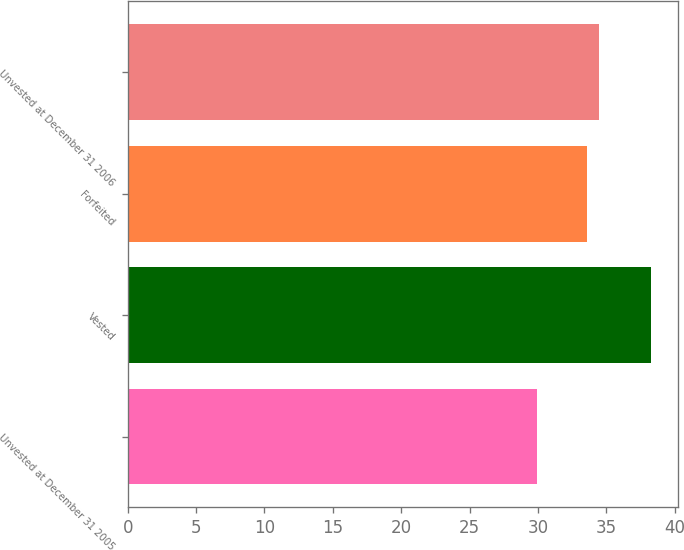Convert chart. <chart><loc_0><loc_0><loc_500><loc_500><bar_chart><fcel>Unvested at December 31 2005<fcel>Vested<fcel>Forfeited<fcel>Unvested at December 31 2006<nl><fcel>29.93<fcel>38.3<fcel>33.61<fcel>34.45<nl></chart> 